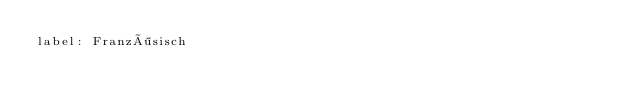<code> <loc_0><loc_0><loc_500><loc_500><_YAML_>label: Französisch
</code> 